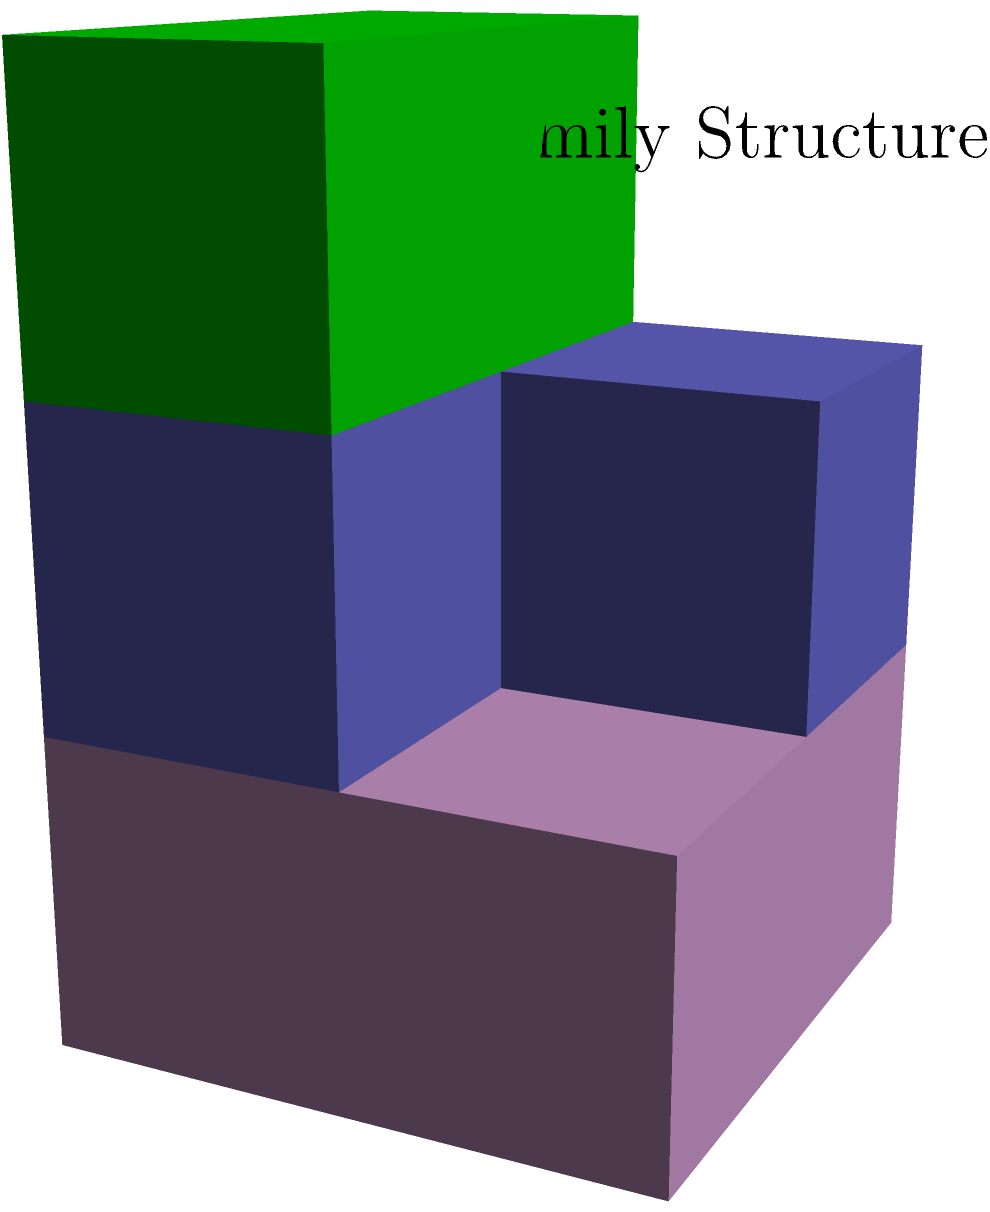In this 3D structure representing a family unit, where pink cubes symbolize the foundation (parents), light blue cubes represent children, and green cubes depict shared experiences, how many total cubes are there? To determine the total number of cubes in this 3D structure, let's count them layer by layer:

1. Base layer (pink cubes - foundation/parents):
   - There are 4 pink cubes in a 2x2 arrangement.
   
2. Middle layer (light blue cubes - children):
   - There are 3 light blue cubes in an L-shape.
   
3. Top layer (green cubes - shared experiences):
   - There are 2 green cubes side by side.

Now, let's sum up the cubes from each layer:
$$ \text{Total cubes} = \text{Base layer} + \text{Middle layer} + \text{Top layer} $$
$$ \text{Total cubes} = 4 + 3 + 2 = 9 $$

Therefore, the total number of cubes in this 3D structure representing a family unit is 9.
Answer: 9 cubes 